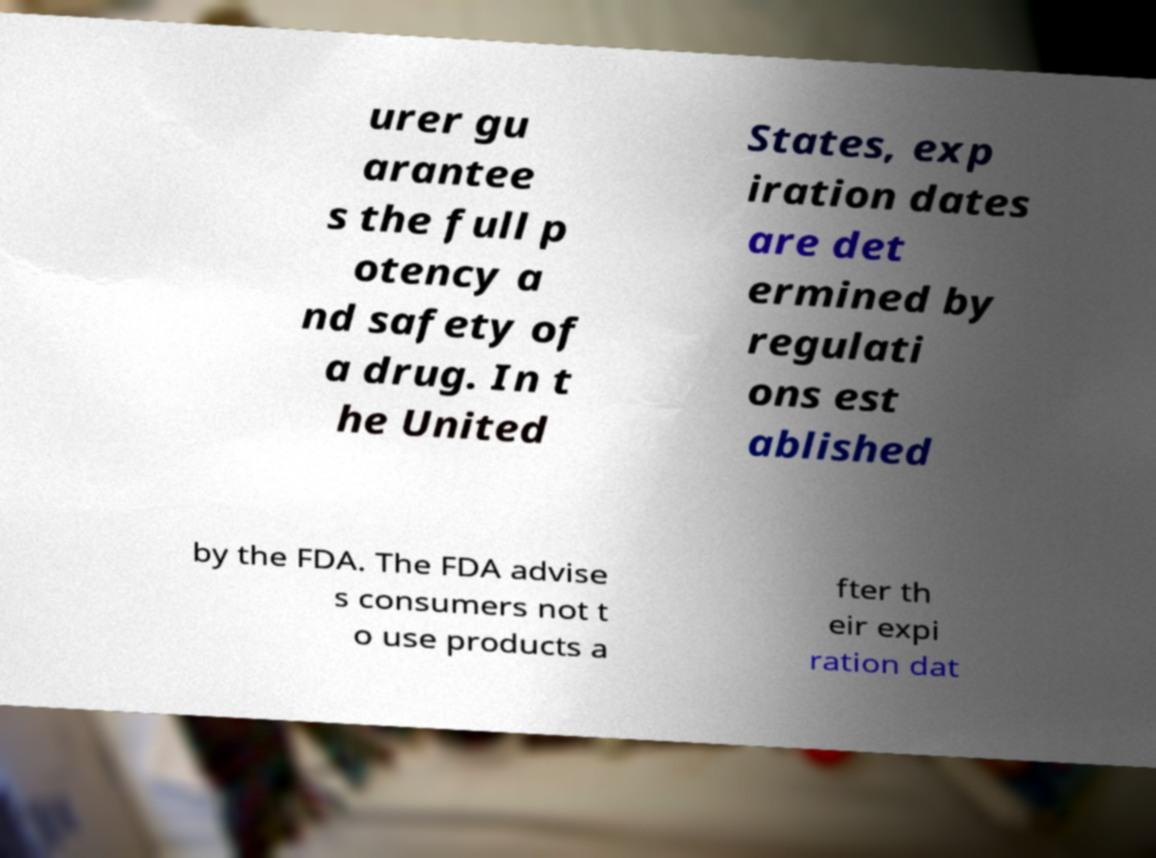There's text embedded in this image that I need extracted. Can you transcribe it verbatim? urer gu arantee s the full p otency a nd safety of a drug. In t he United States, exp iration dates are det ermined by regulati ons est ablished by the FDA. The FDA advise s consumers not t o use products a fter th eir expi ration dat 